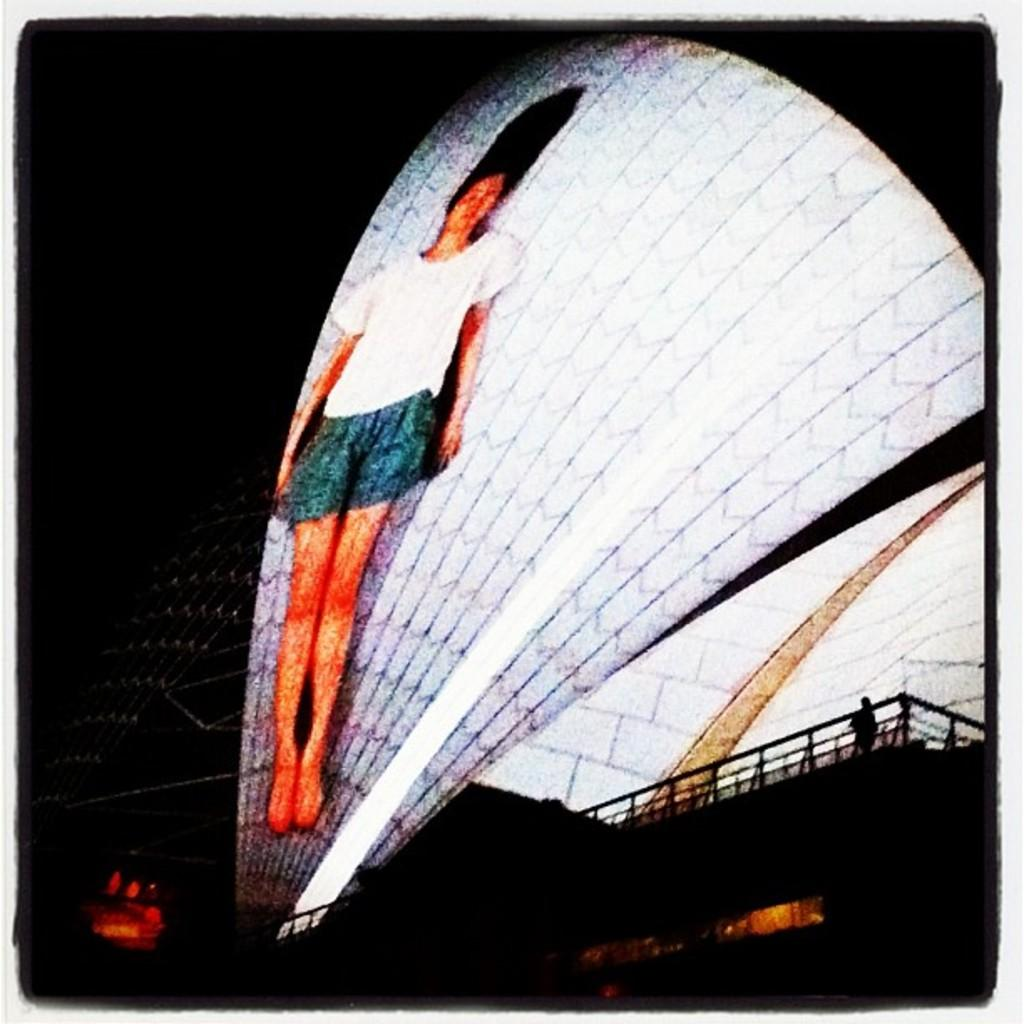What type of event or display is depicted in the image? The image appears to be a light show. Can you describe any specific elements or features of the light show? There is an image of a girl on a building. What type of flower is being discussed by the people in the image? There are no people present in the image, and no flowers are mentioned or depicted. 